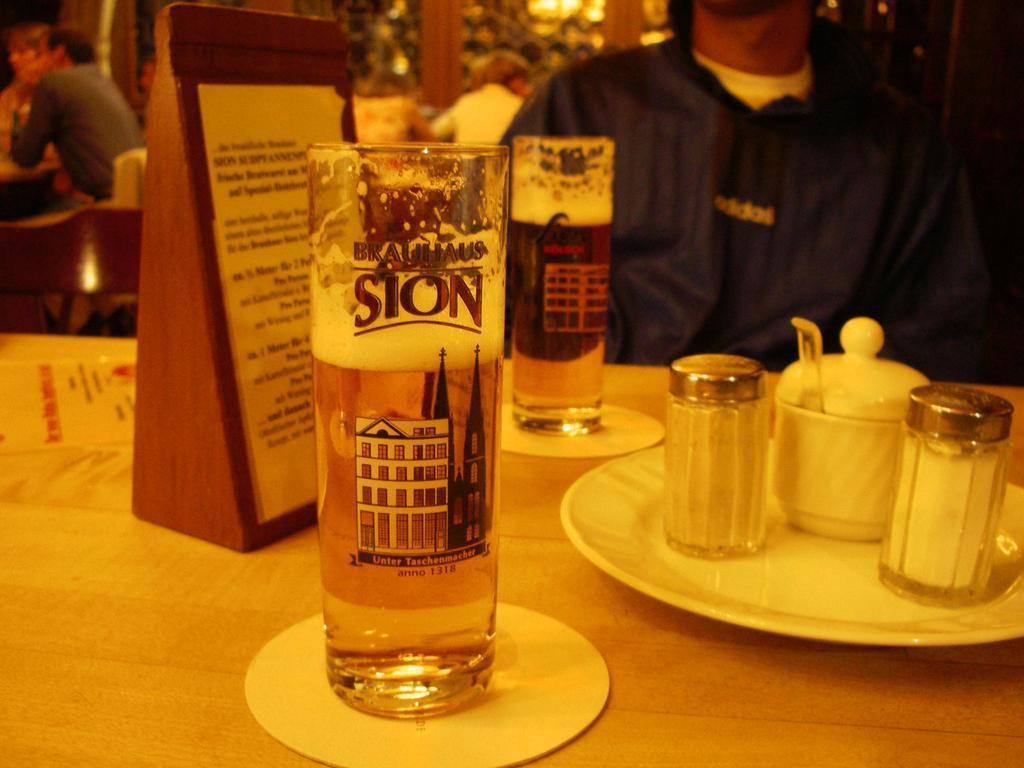<image>
Create a compact narrative representing the image presented. A tall glass of Brauhaus Sion is shown on a table. 